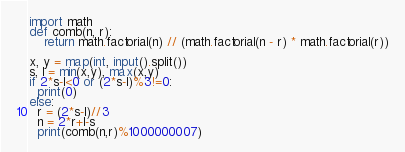<code> <loc_0><loc_0><loc_500><loc_500><_Python_>import math
def comb(n, r):
    return math.factorial(n) // (math.factorial(n - r) * math.factorial(r))

x, y = map(int, input().split())
s, l = min(x,y), max(x,y)
if 2*s-l<0 or (2*s-l)%3!=0:
  print(0)
else:
  r = (2*s-l)//3
  n = 2*r+l-s
  print(comb(n,r)%1000000007)</code> 